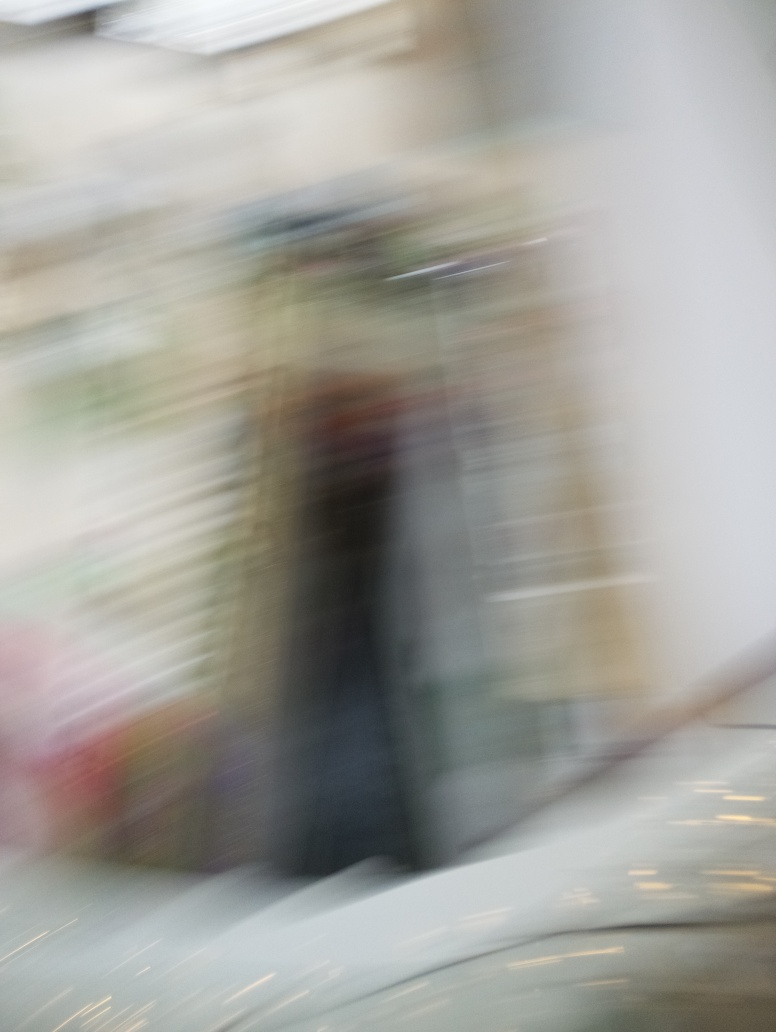What effect does ghosting have on the image?
A. Improvement of color accuracy
B. Reduction of noise
C. Enhancement of details
D. Loss of texture details
Answer with the option's letter from the given choices directly.
 D. 